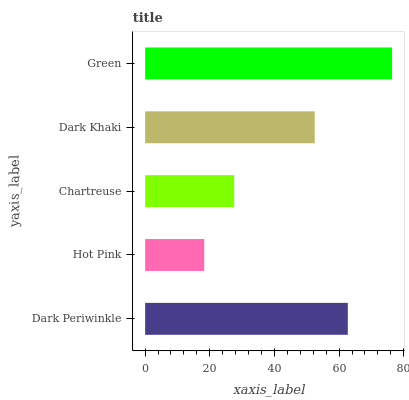Is Hot Pink the minimum?
Answer yes or no. Yes. Is Green the maximum?
Answer yes or no. Yes. Is Chartreuse the minimum?
Answer yes or no. No. Is Chartreuse the maximum?
Answer yes or no. No. Is Chartreuse greater than Hot Pink?
Answer yes or no. Yes. Is Hot Pink less than Chartreuse?
Answer yes or no. Yes. Is Hot Pink greater than Chartreuse?
Answer yes or no. No. Is Chartreuse less than Hot Pink?
Answer yes or no. No. Is Dark Khaki the high median?
Answer yes or no. Yes. Is Dark Khaki the low median?
Answer yes or no. Yes. Is Hot Pink the high median?
Answer yes or no. No. Is Chartreuse the low median?
Answer yes or no. No. 